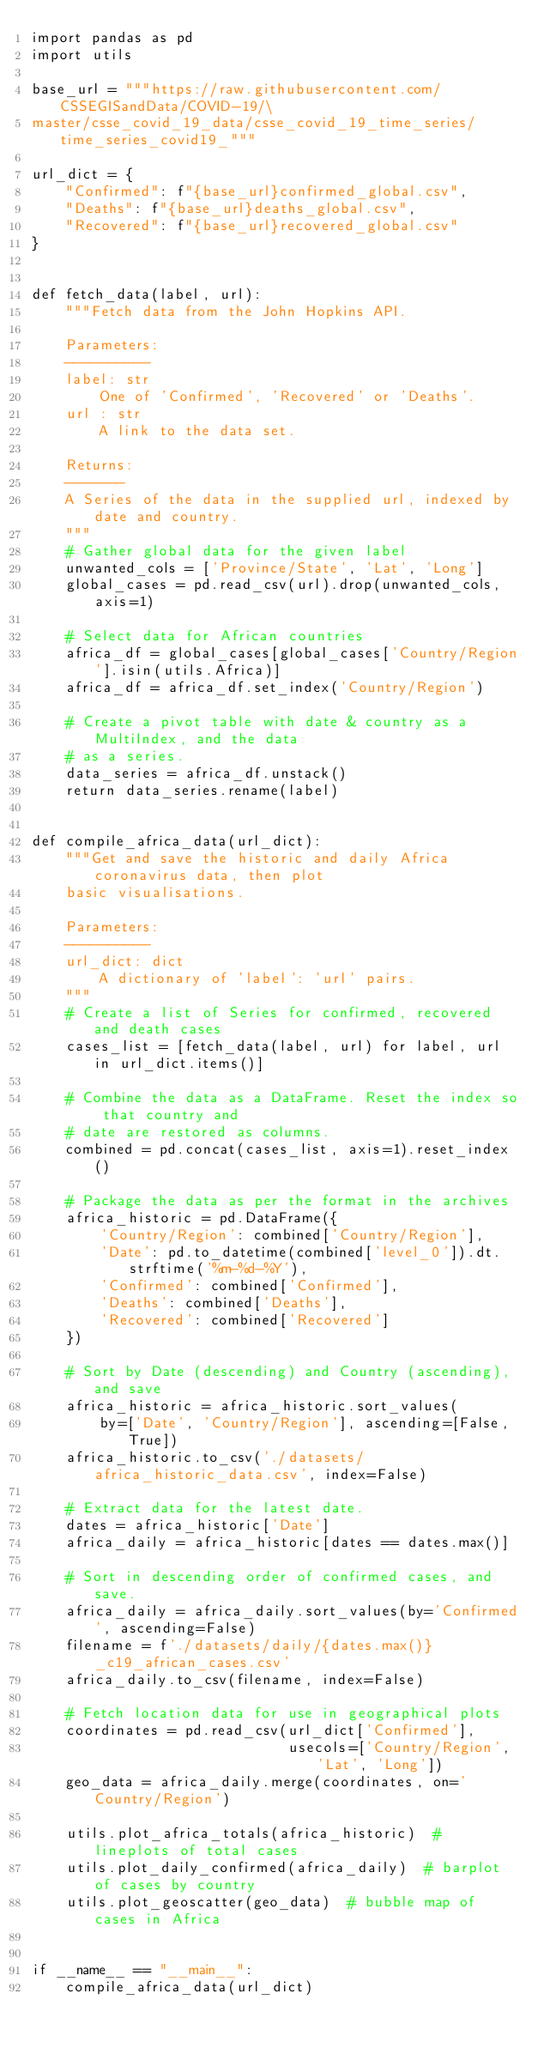<code> <loc_0><loc_0><loc_500><loc_500><_Python_>import pandas as pd
import utils

base_url = """https://raw.githubusercontent.com/CSSEGISandData/COVID-19/\
master/csse_covid_19_data/csse_covid_19_time_series/time_series_covid19_"""

url_dict = {
    "Confirmed": f"{base_url}confirmed_global.csv",
    "Deaths": f"{base_url}deaths_global.csv",
    "Recovered": f"{base_url}recovered_global.csv"
}


def fetch_data(label, url):
    """Fetch data from the John Hopkins API.

    Parameters:
    ----------
    label: str
        One of 'Confirmed', 'Recovered' or 'Deaths'.
    url : str
        A link to the data set.

    Returns:
    -------
    A Series of the data in the supplied url, indexed by date and country.
    """
    # Gather global data for the given label
    unwanted_cols = ['Province/State', 'Lat', 'Long']
    global_cases = pd.read_csv(url).drop(unwanted_cols, axis=1)

    # Select data for African countries
    africa_df = global_cases[global_cases['Country/Region'].isin(utils.Africa)]
    africa_df = africa_df.set_index('Country/Region')

    # Create a pivot table with date & country as a MultiIndex, and the data
    # as a series.
    data_series = africa_df.unstack()
    return data_series.rename(label)


def compile_africa_data(url_dict):
    """Get and save the historic and daily Africa coronavirus data, then plot
    basic visualisations.

    Parameters:
    ----------
    url_dict: dict
        A dictionary of 'label': 'url' pairs.
    """
    # Create a list of Series for confirmed, recovered and death cases
    cases_list = [fetch_data(label, url) for label, url in url_dict.items()]

    # Combine the data as a DataFrame. Reset the index so that country and
    # date are restored as columns.
    combined = pd.concat(cases_list, axis=1).reset_index()

    # Package the data as per the format in the archives
    africa_historic = pd.DataFrame({
        'Country/Region': combined['Country/Region'],
        'Date': pd.to_datetime(combined['level_0']).dt.strftime('%m-%d-%Y'),
        'Confirmed': combined['Confirmed'],
        'Deaths': combined['Deaths'],
        'Recovered': combined['Recovered']
    })

    # Sort by Date (descending) and Country (ascending), and save
    africa_historic = africa_historic.sort_values(
        by=['Date', 'Country/Region'], ascending=[False, True])
    africa_historic.to_csv('./datasets/africa_historic_data.csv', index=False)

    # Extract data for the latest date.
    dates = africa_historic['Date']
    africa_daily = africa_historic[dates == dates.max()]

    # Sort in descending order of confirmed cases, and save.
    africa_daily = africa_daily.sort_values(by='Confirmed', ascending=False)
    filename = f'./datasets/daily/{dates.max()}_c19_african_cases.csv'
    africa_daily.to_csv(filename, index=False)

    # Fetch location data for use in geographical plots
    coordinates = pd.read_csv(url_dict['Confirmed'],
                              usecols=['Country/Region', 'Lat', 'Long'])
    geo_data = africa_daily.merge(coordinates, on='Country/Region')

    utils.plot_africa_totals(africa_historic)  # lineplots of total cases
    utils.plot_daily_confirmed(africa_daily)  # barplot of cases by country
    utils.plot_geoscatter(geo_data)  # bubble map of cases in Africa


if __name__ == "__main__":
    compile_africa_data(url_dict)
</code> 